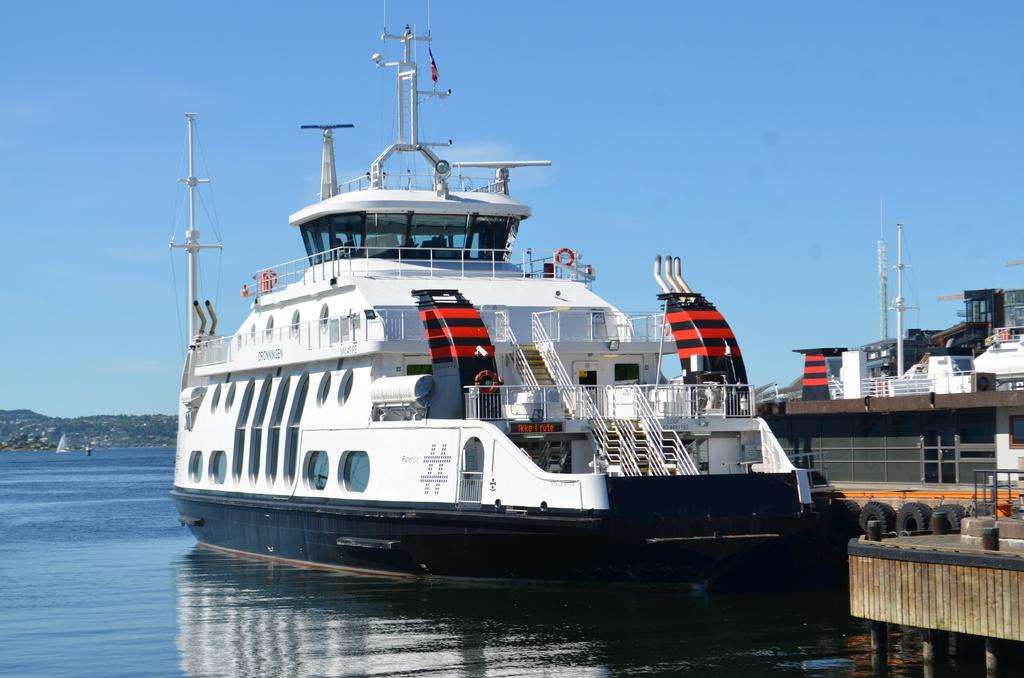What type of vehicles can be seen in the water in the image? There are ships in the water in the image. What natural features can be seen in the background of the image? There are mountains and trees in the background of the image. What is visible at the top of the image? The sky is visible at the top of the image. Where was the image taken? The image was taken near the seashore. Can you tell me how many shoes are visible in the image? There are no shoes present in the image. What type of fruit is being crushed in the image? There is no fruit being crushed in the image. 